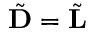Convert formula to latex. <formula><loc_0><loc_0><loc_500><loc_500>\tilde { D } = \tilde { L }</formula> 